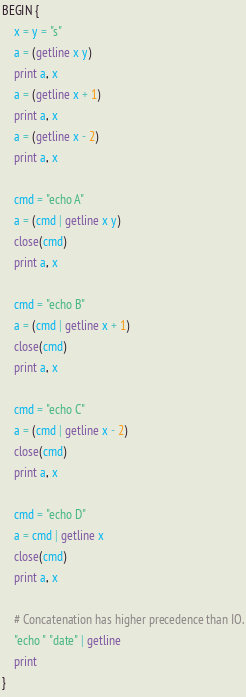Convert code to text. <code><loc_0><loc_0><loc_500><loc_500><_Awk_>BEGIN {
	x = y = "s"
	a = (getline x y)
	print a, x
	a = (getline x + 1)
	print a, x
	a = (getline x - 2)
	print a, x

	cmd = "echo A"
	a = (cmd | getline x y)
	close(cmd)
	print a, x

	cmd = "echo B"
	a = (cmd | getline x + 1)
	close(cmd)
	print a, x

	cmd = "echo C"
	a = (cmd | getline x - 2)
	close(cmd)
	print a, x

	cmd = "echo D"
	a = cmd | getline x
	close(cmd)
	print a, x

	# Concatenation has higher precedence than IO.
	"echo " "date" | getline
	print
}
</code> 